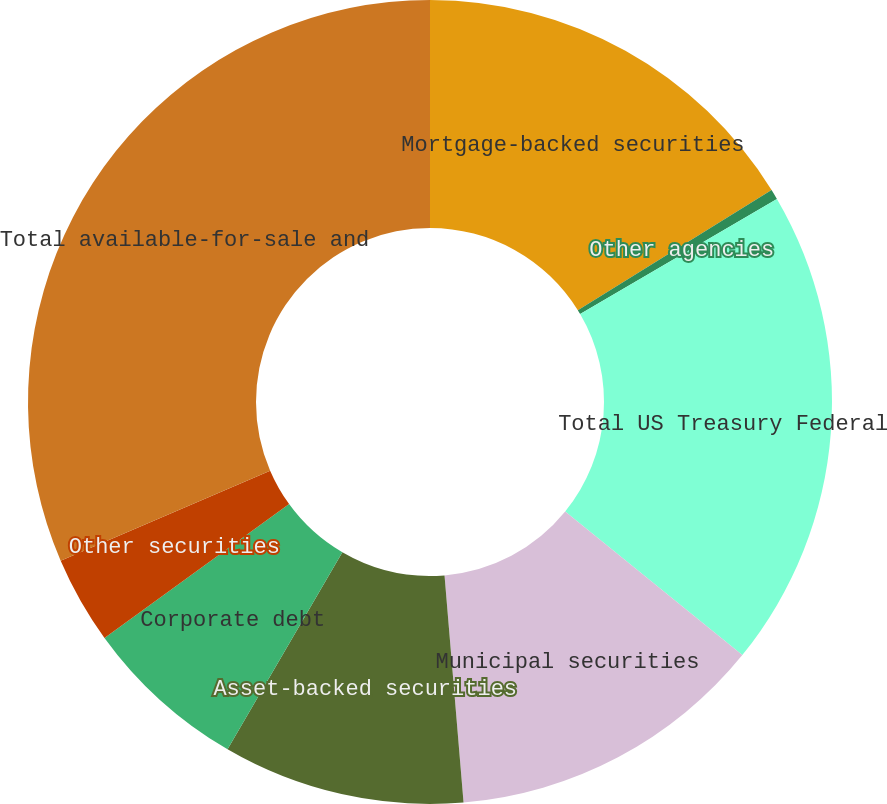Convert chart to OTSL. <chart><loc_0><loc_0><loc_500><loc_500><pie_chart><fcel>Mortgage-backed securities<fcel>Other agencies<fcel>Total US Treasury Federal<fcel>Municipal securities<fcel>Asset-backed securities<fcel>Corporate debt<fcel>Other securities<fcel>Total available-for-sale and<nl><fcel>16.16%<fcel>0.41%<fcel>19.27%<fcel>12.83%<fcel>9.73%<fcel>6.62%<fcel>3.52%<fcel>31.46%<nl></chart> 